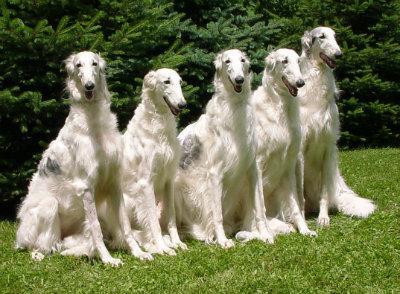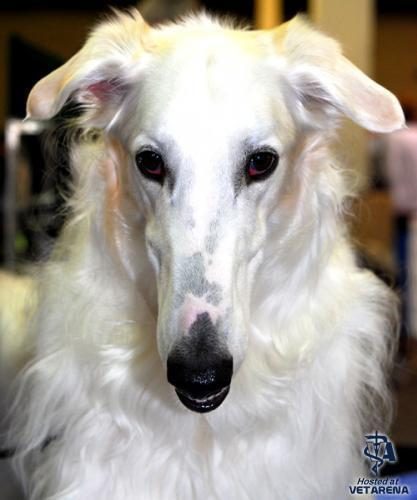The first image is the image on the left, the second image is the image on the right. Evaluate the accuracy of this statement regarding the images: "There is only one dog in both pictures". Is it true? Answer yes or no. No. The first image is the image on the left, the second image is the image on the right. For the images shown, is this caption "There are more than two dogs present." true? Answer yes or no. Yes. 